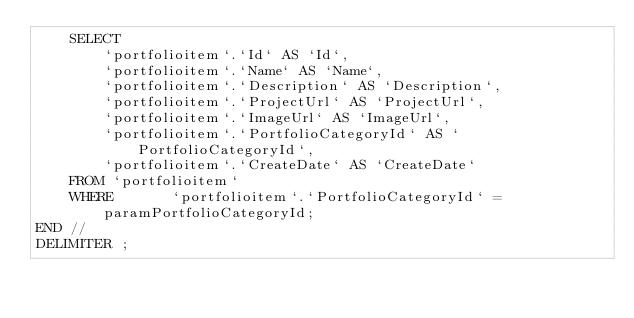Convert code to text. <code><loc_0><loc_0><loc_500><loc_500><_SQL_>	SELECT
		`portfolioitem`.`Id` AS `Id`,
		`portfolioitem`.`Name` AS `Name`,
		`portfolioitem`.`Description` AS `Description`,
		`portfolioitem`.`ProjectUrl` AS `ProjectUrl`,
		`portfolioitem`.`ImageUrl` AS `ImageUrl`,
		`portfolioitem`.`PortfolioCategoryId` AS `PortfolioCategoryId`,
		`portfolioitem`.`CreateDate` AS `CreateDate`
	FROM `portfolioitem`
	WHERE 		`portfolioitem`.`PortfolioCategoryId` = paramPortfolioCategoryId;
END //
DELIMITER ;</code> 